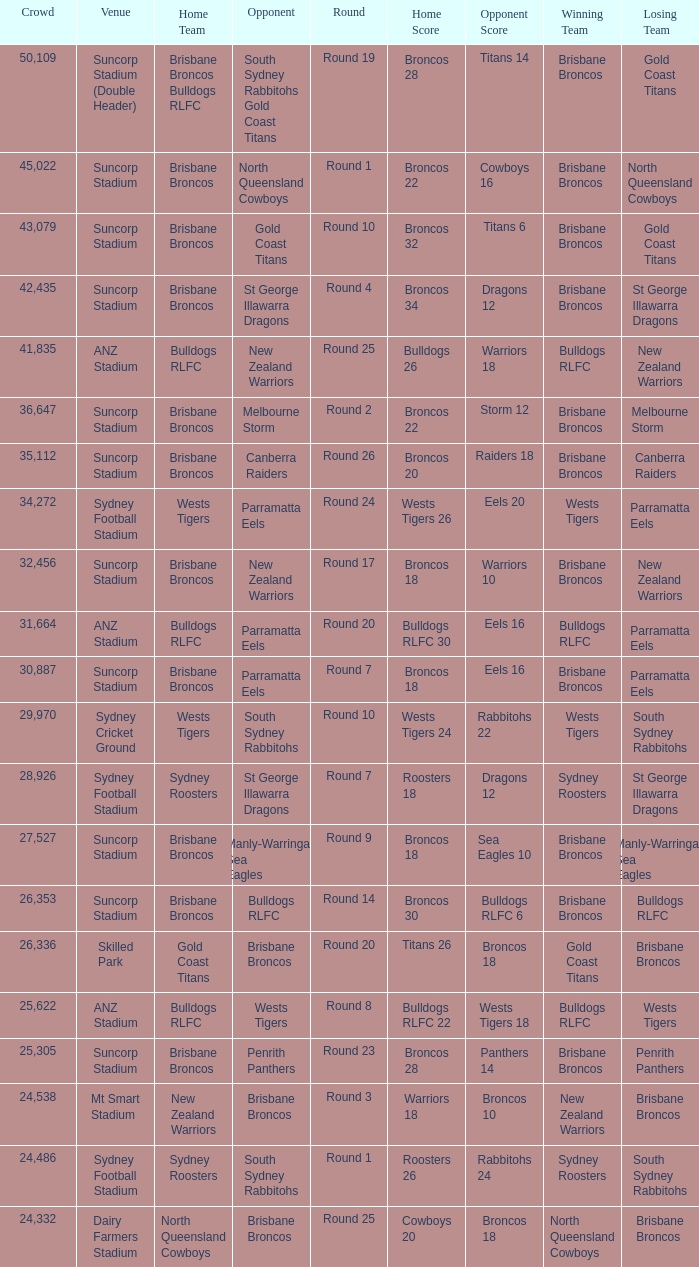What was the attendance at Round 9? 1.0. 